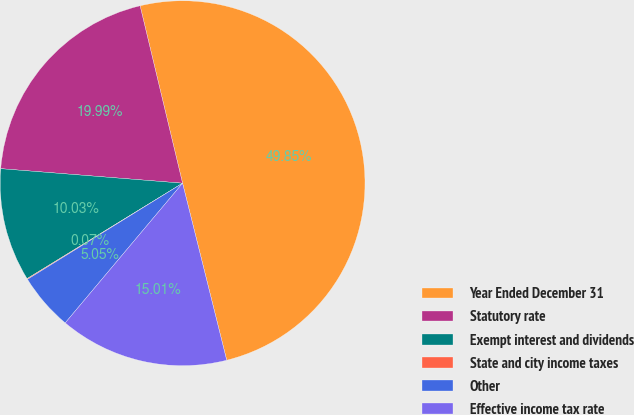Convert chart to OTSL. <chart><loc_0><loc_0><loc_500><loc_500><pie_chart><fcel>Year Ended December 31<fcel>Statutory rate<fcel>Exempt interest and dividends<fcel>State and city income taxes<fcel>Other<fcel>Effective income tax rate<nl><fcel>49.85%<fcel>19.99%<fcel>10.03%<fcel>0.07%<fcel>5.05%<fcel>15.01%<nl></chart> 